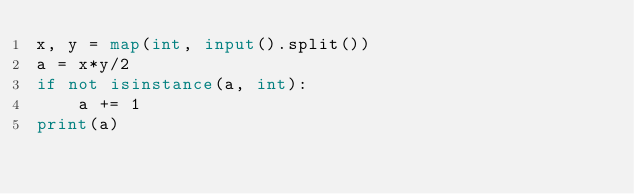<code> <loc_0><loc_0><loc_500><loc_500><_Python_>x, y = map(int, input().split())
a = x*y/2
if not isinstance(a, int):
    a += 1
print(a)
</code> 